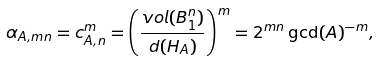<formula> <loc_0><loc_0><loc_500><loc_500>\alpha _ { A , m n } = c _ { A , n } ^ { m } = \left ( \frac { v o l ( B _ { 1 } ^ { n } ) } { d ( H _ { A } ) } \right ) ^ { m } = 2 ^ { m n } \gcd ( A ) ^ { - m } ,</formula> 